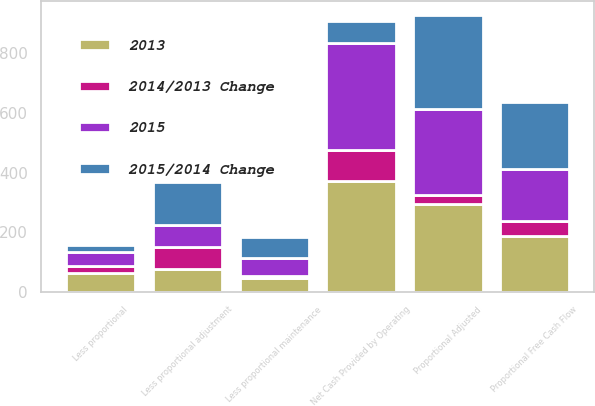Convert chart. <chart><loc_0><loc_0><loc_500><loc_500><stacked_bar_chart><ecel><fcel>Net Cash Provided by Operating<fcel>Less proportional adjustment<fcel>Proportional Adjusted<fcel>Less proportional maintenance<fcel>Less proportional<fcel>Proportional Free Cash Flow<nl><fcel>2015/2014 Change<fcel>73<fcel>145<fcel>317<fcel>70<fcel>23<fcel>224<nl><fcel>2015<fcel>359<fcel>73<fcel>286<fcel>63<fcel>47<fcel>176<nl><fcel>2013<fcel>373<fcel>78<fcel>295<fcel>45<fcel>62<fcel>188<nl><fcel>2014/2013 Change<fcel>103<fcel>72<fcel>31<fcel>7<fcel>24<fcel>48<nl></chart> 